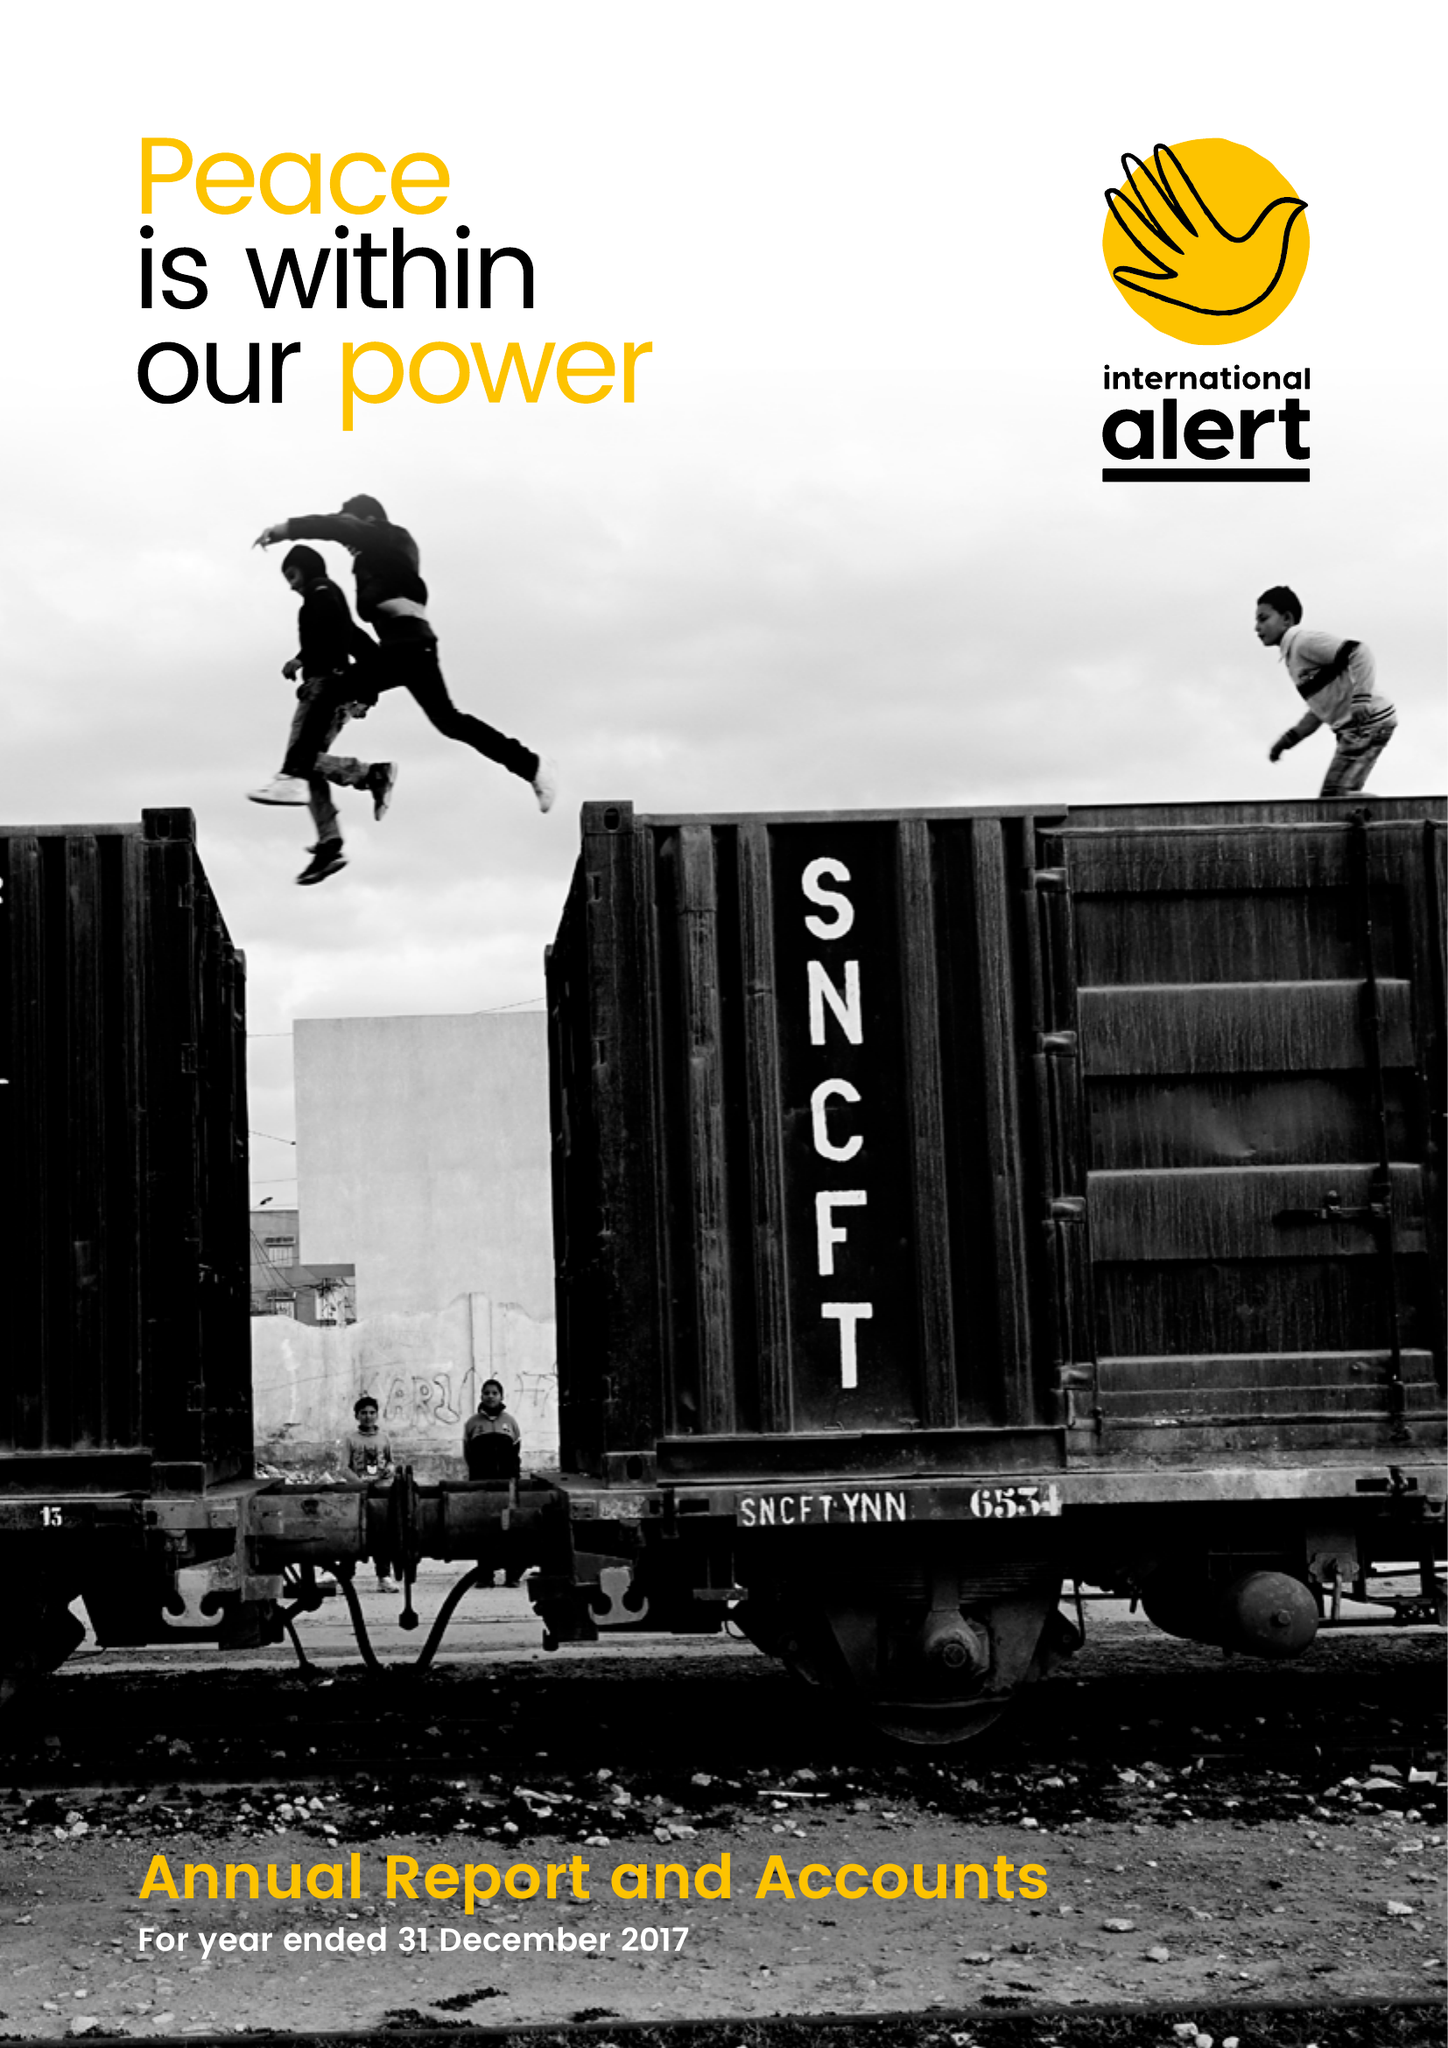What is the value for the report_date?
Answer the question using a single word or phrase. 2017-12-31 